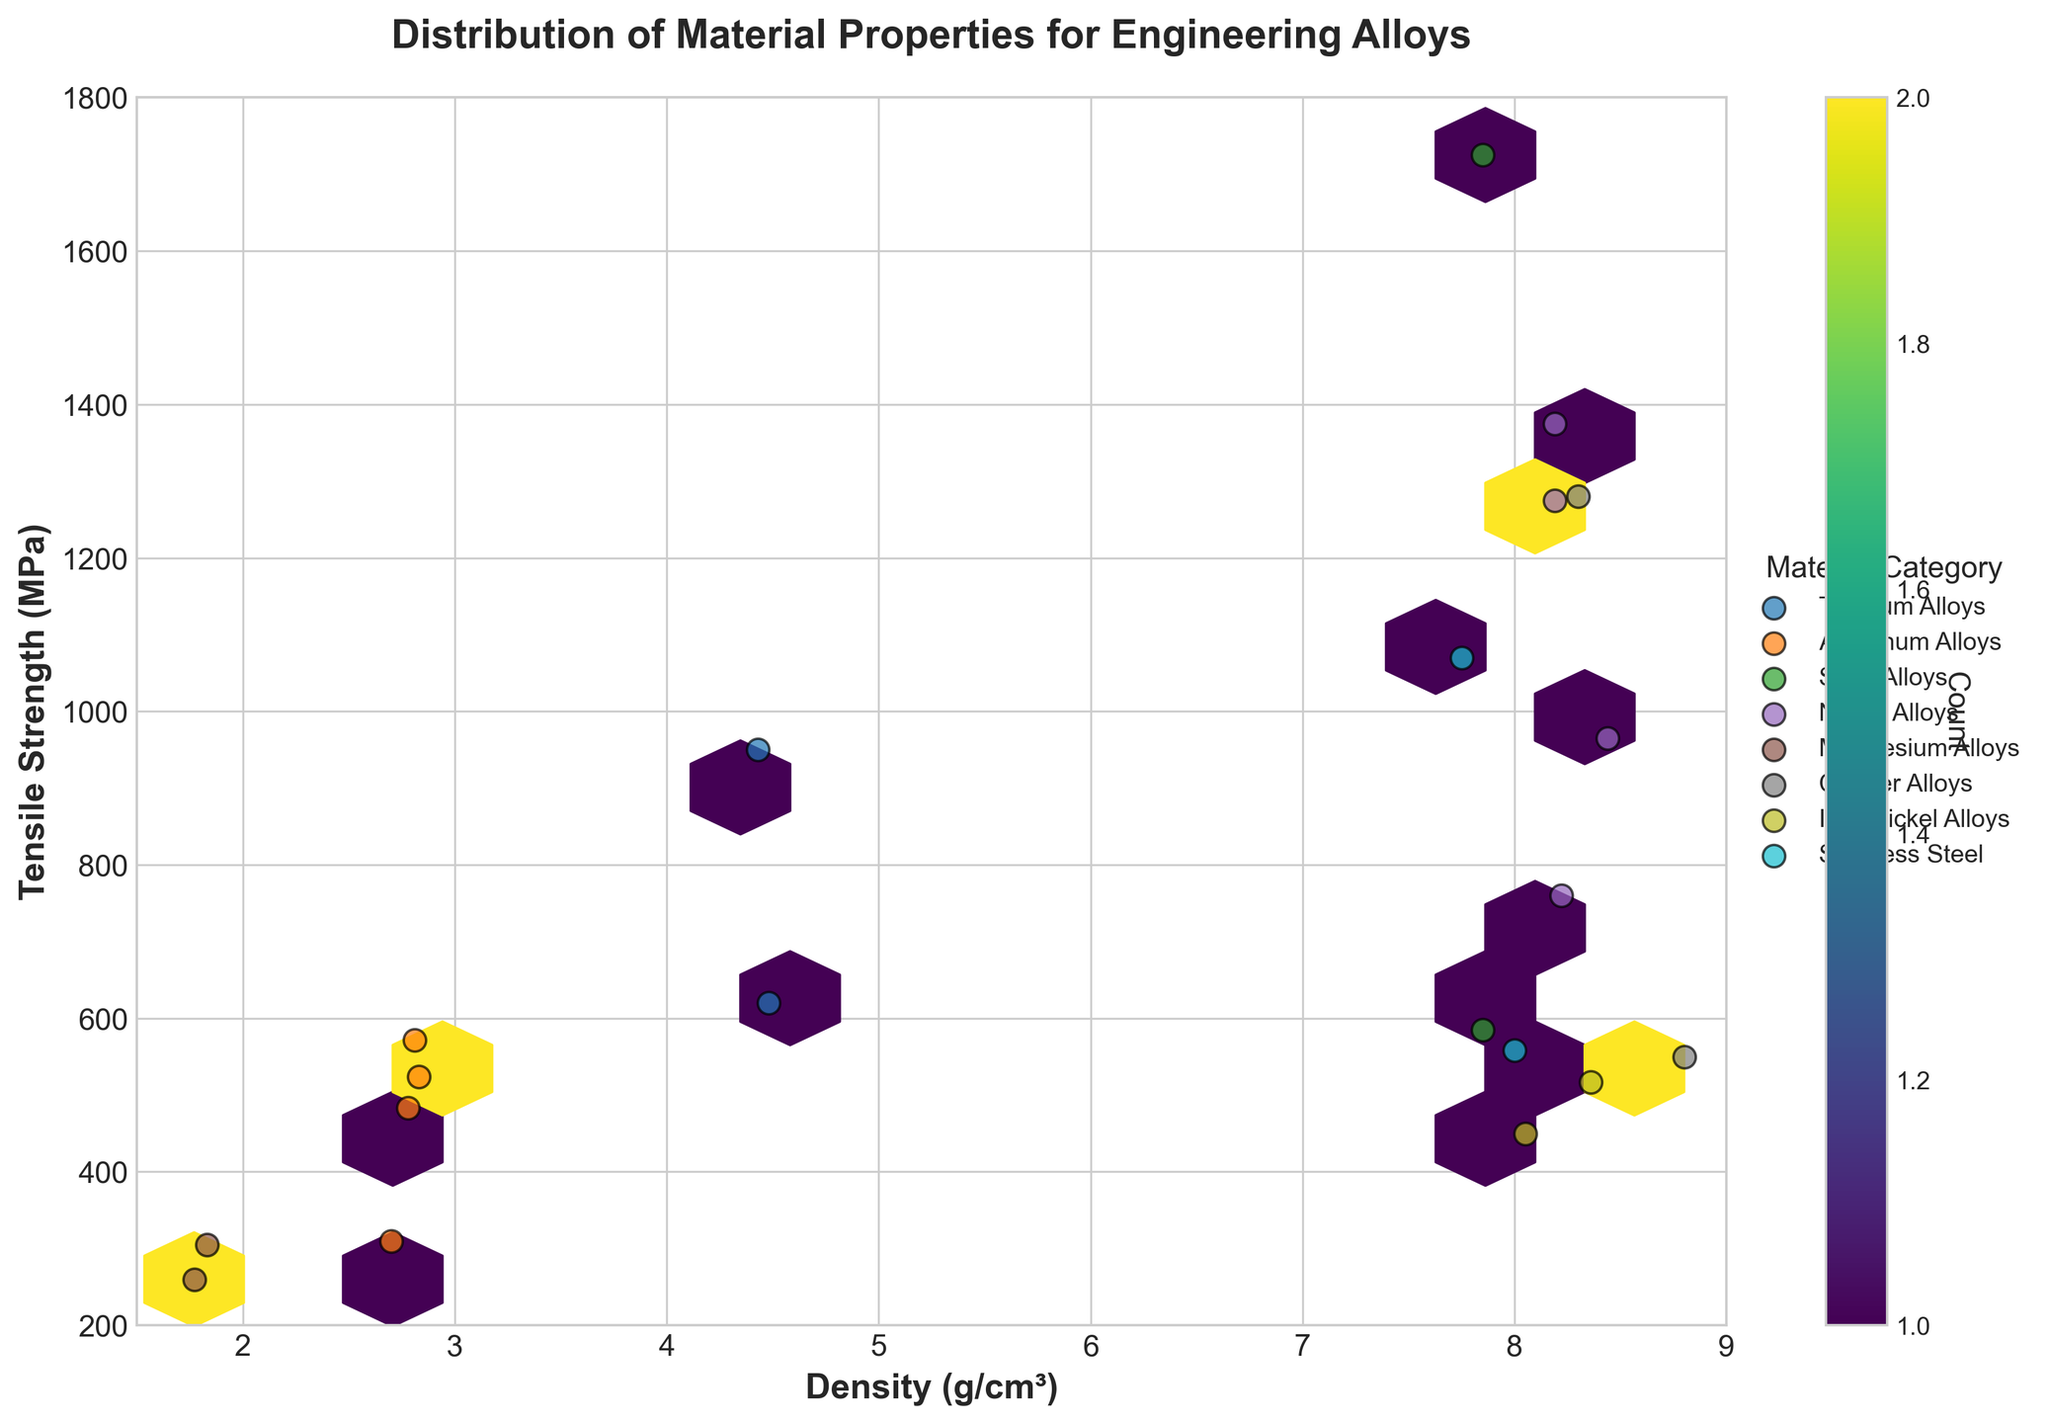What is the title of the figure? The title of the figure is found at the top center of the plot, written in bold. It reads "Distribution of Material Properties for Engineering Alloys".
Answer: Distribution of Material Properties for Engineering Alloys How many material categories are there in the plot? To determine the number of material categories, look at the legend on the right side of the plot. It lists all the material categories. There are 7 different categories: Titanium Alloys, Aluminum Alloys, Steel Alloys, Nickel Alloys, Magnesium Alloys, Copper Alloys, and Iron-Nickel Alloys.
Answer: 7 What is the range of tensile strength values shown on the y-axis? Check the y-axis on the left side of the plot. The range is shown between the minimum and maximum values, which are marked from 200 MPa to 1800 MPa.
Answer: 200 to 1800 MPa How does the density of Nickel Alloys compare to that of Magnesium Alloys? By looking at the scatter points for Nickel Alloys (color-coded according to the legend) and Magnesium Alloys, we see that Nickel Alloys are clustered around densities greater than 8 g/cm³ while Magnesium Alloys have densities around 1.77 and 1.83 g/cm³. This shows that Nickel Alloys generally have much higher densities compared to Magnesium Alloys.
Answer: Nickel Alloys have higher densities than Magnesium Alloys Which category has the maximum tensile strength, and what is that value? Looking at the scatter points, the highest point on the y-axis belongs to the Steel Alloys category. The highest tensile strength for Steel Alloys, indicated by the legend, is AISI 4340 with a value of 1725 MPa.
Answer: Steel Alloys, 1725 MPa What is the average tensile strength for Aluminum Alloys in the figure? First, list tensile strengths of Aluminum Alloys: Al 7075-T6 (572), Al 6061-T6 (310), 2024-T3 (483), and 7050-T7451 (524). Add these values: 572 + 310 + 483 + 524 = 1889. There are 4 data points, so divide the sum by the number of data points: 1889 / 4 = 472.25 MPa.
Answer: 472.25 MPa Which has a higher count of data points within their category, Stainless Steel or Iron-Nickel Alloys? Each category's data points can be counted by its representation in the scatter plot. Stainless Steel has 2 points (17-4 PH, 316L) and Iron-Nickel Alloys also has 2 points (Invar 36, Kovar). The counts are equal.
Answer: The counts are equal How many points fall within the density range of 8.0 to 9.0 g/cm³, according to the hexbin plot? The hexbin plot's color map, combined with direct observation of individual scatter points within the specified density range, helps to count the points. There are 8 points within the 8.0 to 9.0 g/cm³ density range, spread across different material categories.
Answer: 8 What colors represent Titanium Alloys and Nickel Alloys on the plot? The colors for categories are shown in the legend. Titanium Alloys are represented by an orange color and Nickel Alloys by a purple color.
Answer: Orange for Titanium Alloys, Purple for Nickel Alloys 